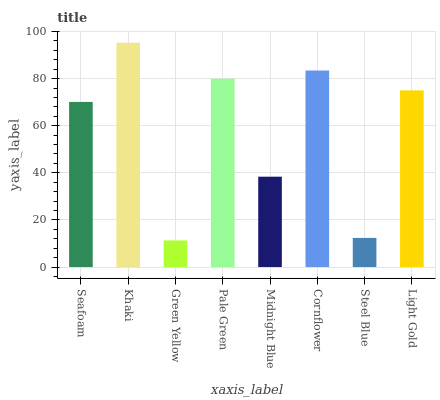Is Green Yellow the minimum?
Answer yes or no. Yes. Is Khaki the maximum?
Answer yes or no. Yes. Is Khaki the minimum?
Answer yes or no. No. Is Green Yellow the maximum?
Answer yes or no. No. Is Khaki greater than Green Yellow?
Answer yes or no. Yes. Is Green Yellow less than Khaki?
Answer yes or no. Yes. Is Green Yellow greater than Khaki?
Answer yes or no. No. Is Khaki less than Green Yellow?
Answer yes or no. No. Is Light Gold the high median?
Answer yes or no. Yes. Is Seafoam the low median?
Answer yes or no. Yes. Is Midnight Blue the high median?
Answer yes or no. No. Is Pale Green the low median?
Answer yes or no. No. 